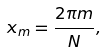Convert formula to latex. <formula><loc_0><loc_0><loc_500><loc_500>x _ { m } = { \frac { 2 \pi m } { N } } ,</formula> 